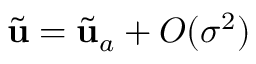Convert formula to latex. <formula><loc_0><loc_0><loc_500><loc_500>\tilde { u } = \tilde { u } _ { a } + O ( \sigma ^ { 2 } )</formula> 